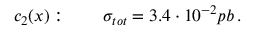Convert formula to latex. <formula><loc_0><loc_0><loc_500><loc_500>c _ { 2 } ( x ) \colon \quad \sigma _ { t o t } = 3 . 4 \cdot 1 0 ^ { - 2 } p b \, .</formula> 